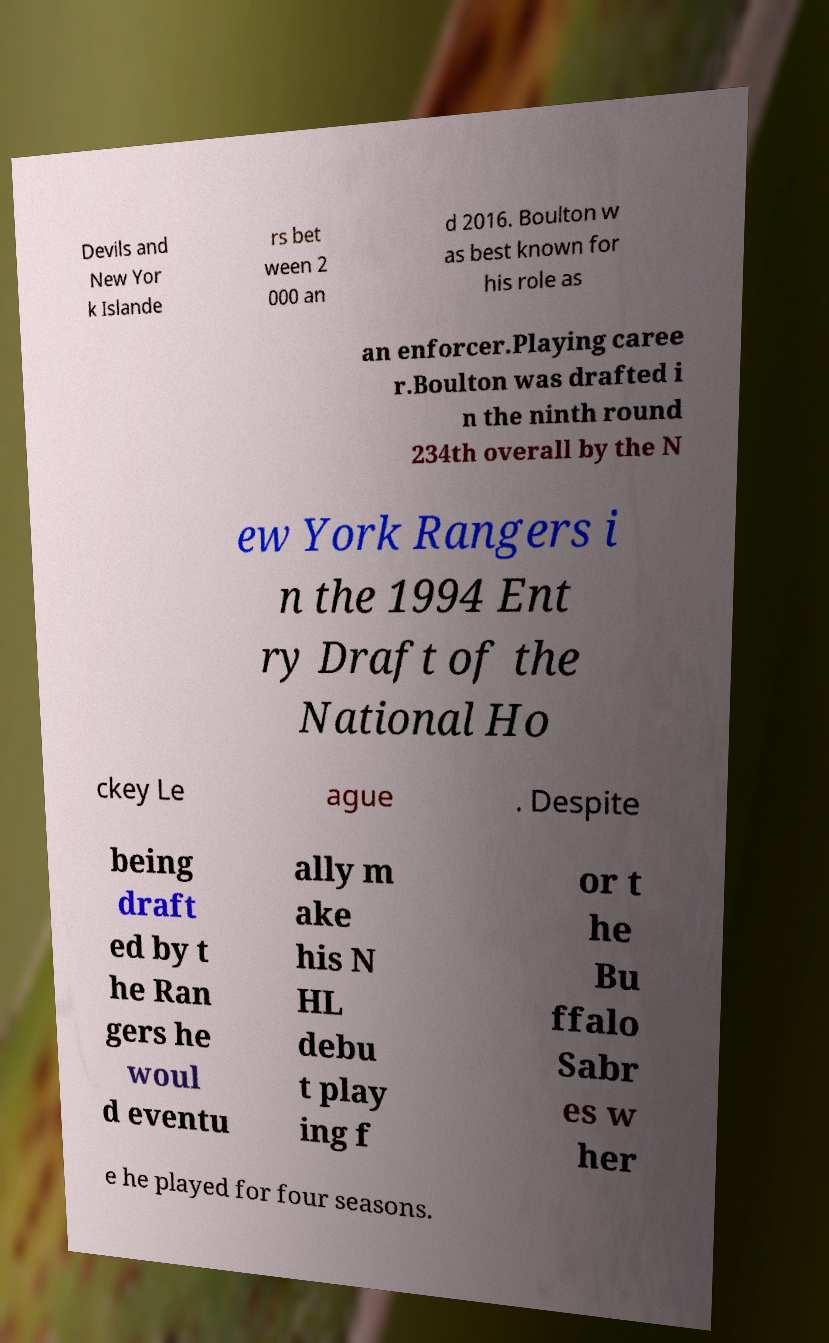There's text embedded in this image that I need extracted. Can you transcribe it verbatim? Devils and New Yor k Islande rs bet ween 2 000 an d 2016. Boulton w as best known for his role as an enforcer.Playing caree r.Boulton was drafted i n the ninth round 234th overall by the N ew York Rangers i n the 1994 Ent ry Draft of the National Ho ckey Le ague . Despite being draft ed by t he Ran gers he woul d eventu ally m ake his N HL debu t play ing f or t he Bu ffalo Sabr es w her e he played for four seasons. 